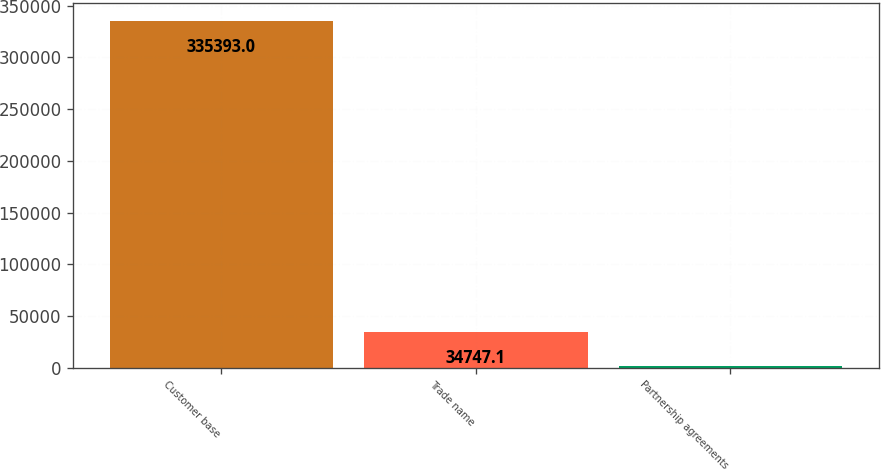<chart> <loc_0><loc_0><loc_500><loc_500><bar_chart><fcel>Customer base<fcel>Trade name<fcel>Partnership agreements<nl><fcel>335393<fcel>34747.1<fcel>1342<nl></chart> 